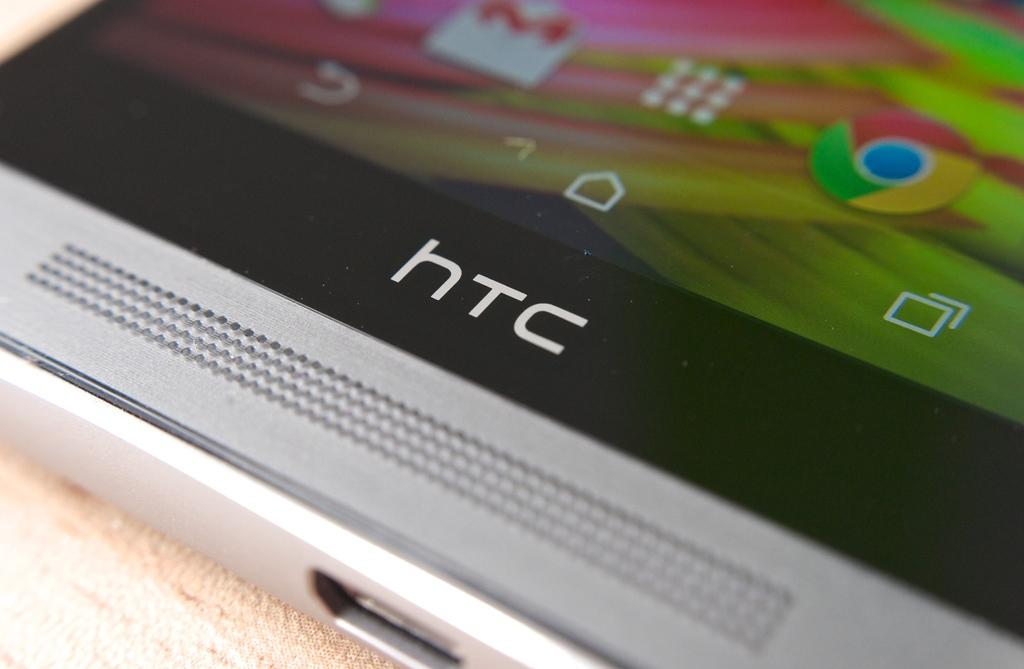<image>
Give a short and clear explanation of the subsequent image. a phone with the letters htc on it 